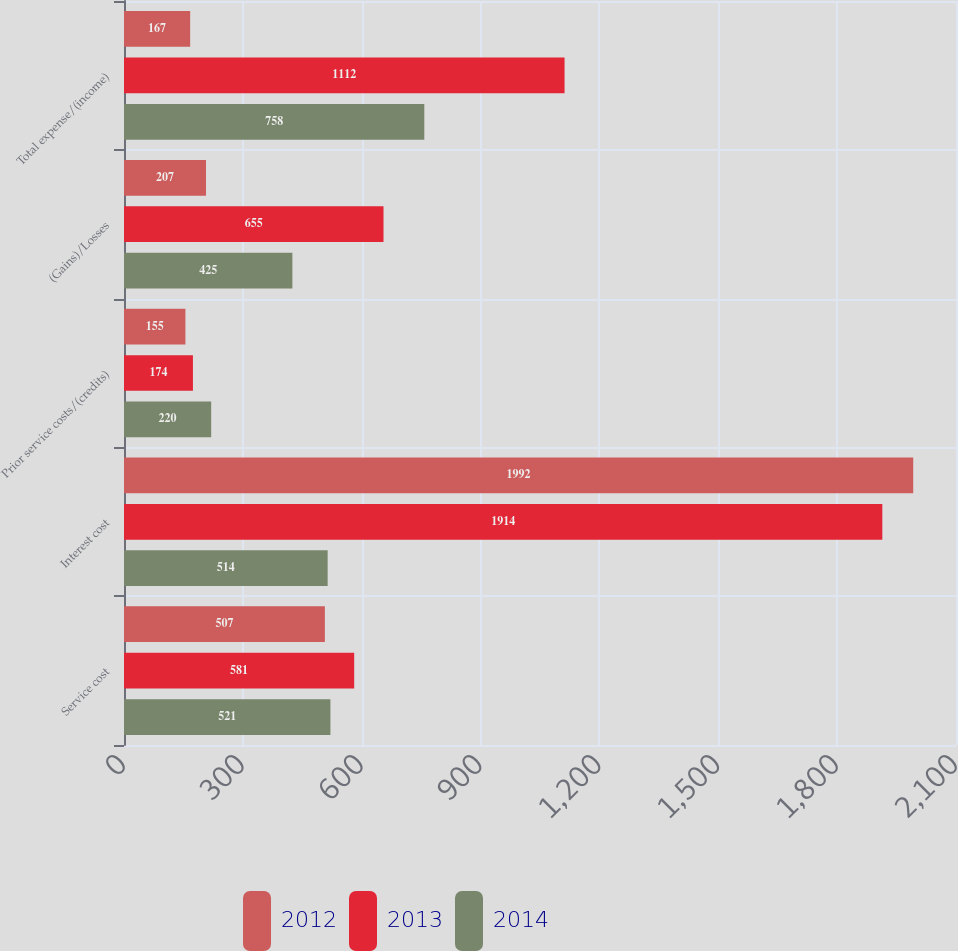Convert chart. <chart><loc_0><loc_0><loc_500><loc_500><stacked_bar_chart><ecel><fcel>Service cost<fcel>Interest cost<fcel>Prior service costs/(credits)<fcel>(Gains)/Losses<fcel>Total expense/(income)<nl><fcel>2012<fcel>507<fcel>1992<fcel>155<fcel>207<fcel>167<nl><fcel>2013<fcel>581<fcel>1914<fcel>174<fcel>655<fcel>1112<nl><fcel>2014<fcel>521<fcel>514<fcel>220<fcel>425<fcel>758<nl></chart> 